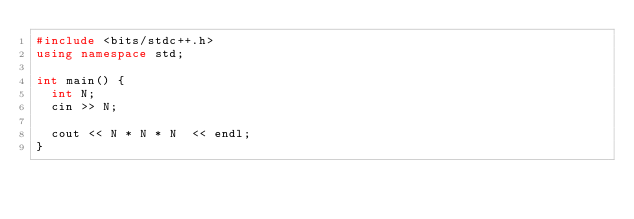Convert code to text. <code><loc_0><loc_0><loc_500><loc_500><_C++_>#include <bits/stdc++.h>
using namespace std;

int main() {
  int N;
  cin >> N;

  cout << N * N * N  << endl;
}</code> 